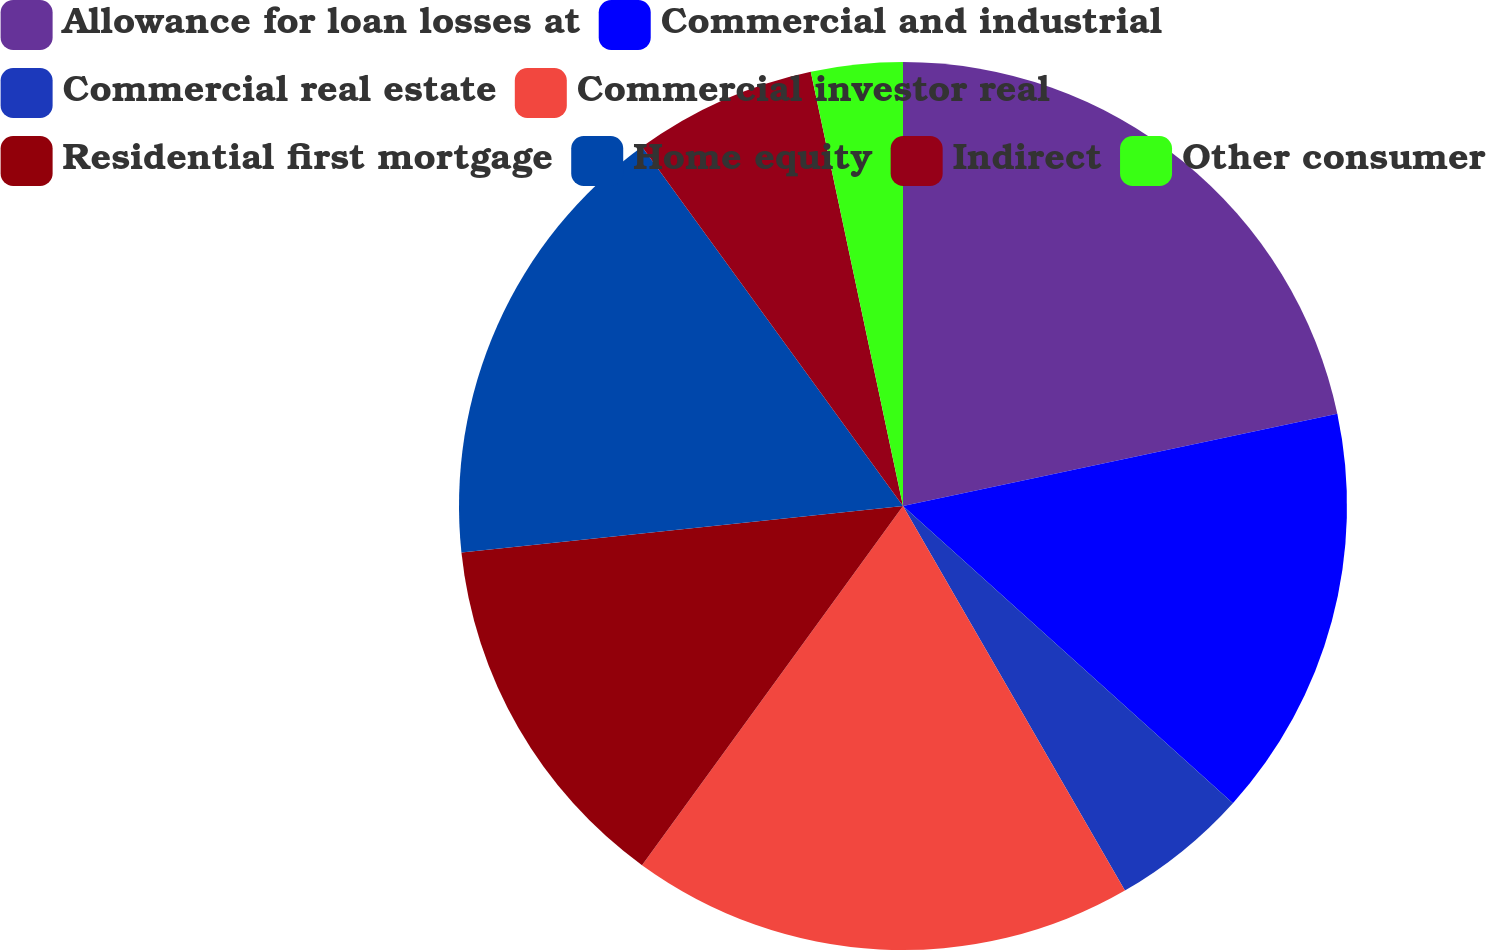Convert chart to OTSL. <chart><loc_0><loc_0><loc_500><loc_500><pie_chart><fcel>Allowance for loan losses at<fcel>Commercial and industrial<fcel>Commercial real estate<fcel>Commercial investor real<fcel>Residential first mortgage<fcel>Home equity<fcel>Indirect<fcel>Other consumer<nl><fcel>21.67%<fcel>15.0%<fcel>5.0%<fcel>18.33%<fcel>13.33%<fcel>16.67%<fcel>6.67%<fcel>3.33%<nl></chart> 